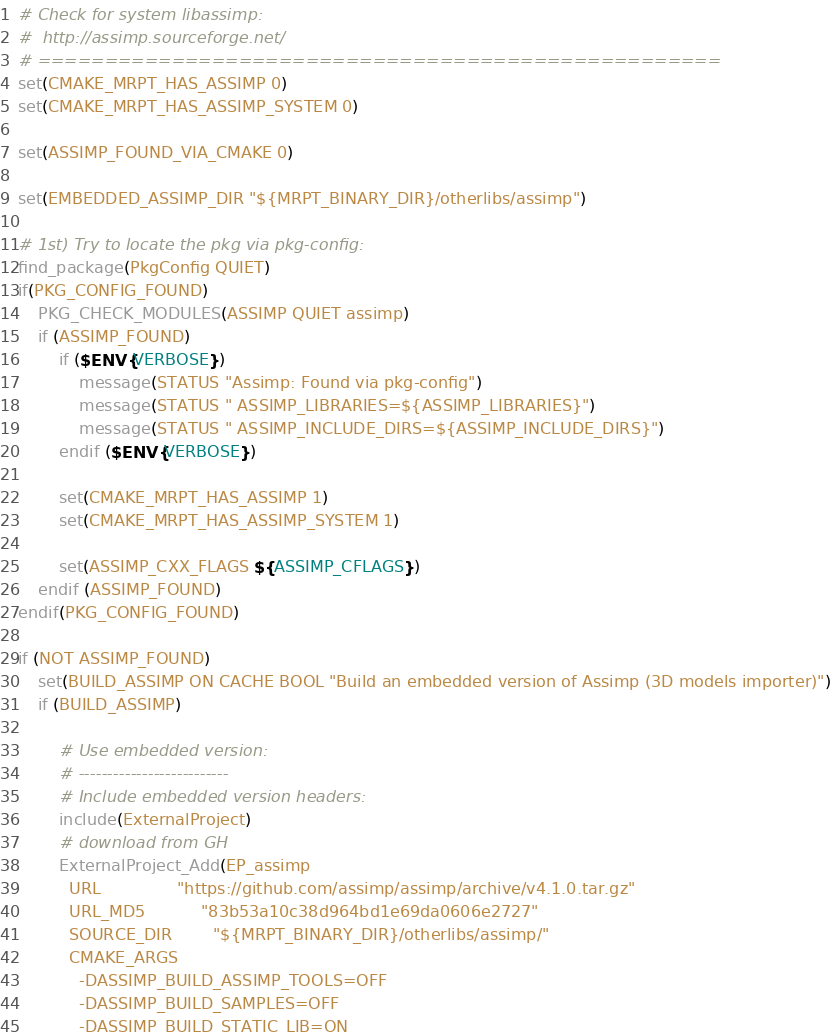Convert code to text. <code><loc_0><loc_0><loc_500><loc_500><_CMake_># Check for system libassimp:
#  http://assimp.sourceforge.net/
# ===================================================
set(CMAKE_MRPT_HAS_ASSIMP 0)
set(CMAKE_MRPT_HAS_ASSIMP_SYSTEM 0)

set(ASSIMP_FOUND_VIA_CMAKE 0)

set(EMBEDDED_ASSIMP_DIR "${MRPT_BINARY_DIR}/otherlibs/assimp")

# 1st) Try to locate the pkg via pkg-config:
find_package(PkgConfig QUIET)
if(PKG_CONFIG_FOUND)
	PKG_CHECK_MODULES(ASSIMP QUIET assimp)
	if (ASSIMP_FOUND)
		if ($ENV{VERBOSE})
			message(STATUS "Assimp: Found via pkg-config")
			message(STATUS " ASSIMP_LIBRARIES=${ASSIMP_LIBRARIES}")
			message(STATUS " ASSIMP_INCLUDE_DIRS=${ASSIMP_INCLUDE_DIRS}")
		endif ($ENV{VERBOSE})

		set(CMAKE_MRPT_HAS_ASSIMP 1)
		set(CMAKE_MRPT_HAS_ASSIMP_SYSTEM 1)

		set(ASSIMP_CXX_FLAGS ${ASSIMP_CFLAGS})
	endif (ASSIMP_FOUND)
endif(PKG_CONFIG_FOUND)

if (NOT ASSIMP_FOUND)
	set(BUILD_ASSIMP ON CACHE BOOL "Build an embedded version of Assimp (3D models importer)")
	if (BUILD_ASSIMP)

		# Use embedded version:
		# --------------------------
		# Include embedded version headers:
		include(ExternalProject)
		# download from GH
		ExternalProject_Add(EP_assimp
		  URL               "https://github.com/assimp/assimp/archive/v4.1.0.tar.gz"
		  URL_MD5           "83b53a10c38d964bd1e69da0606e2727"
		  SOURCE_DIR        "${MRPT_BINARY_DIR}/otherlibs/assimp/"
		  CMAKE_ARGS 
			-DASSIMP_BUILD_ASSIMP_TOOLS=OFF
			-DASSIMP_BUILD_SAMPLES=OFF
			-DASSIMP_BUILD_STATIC_LIB=ON</code> 